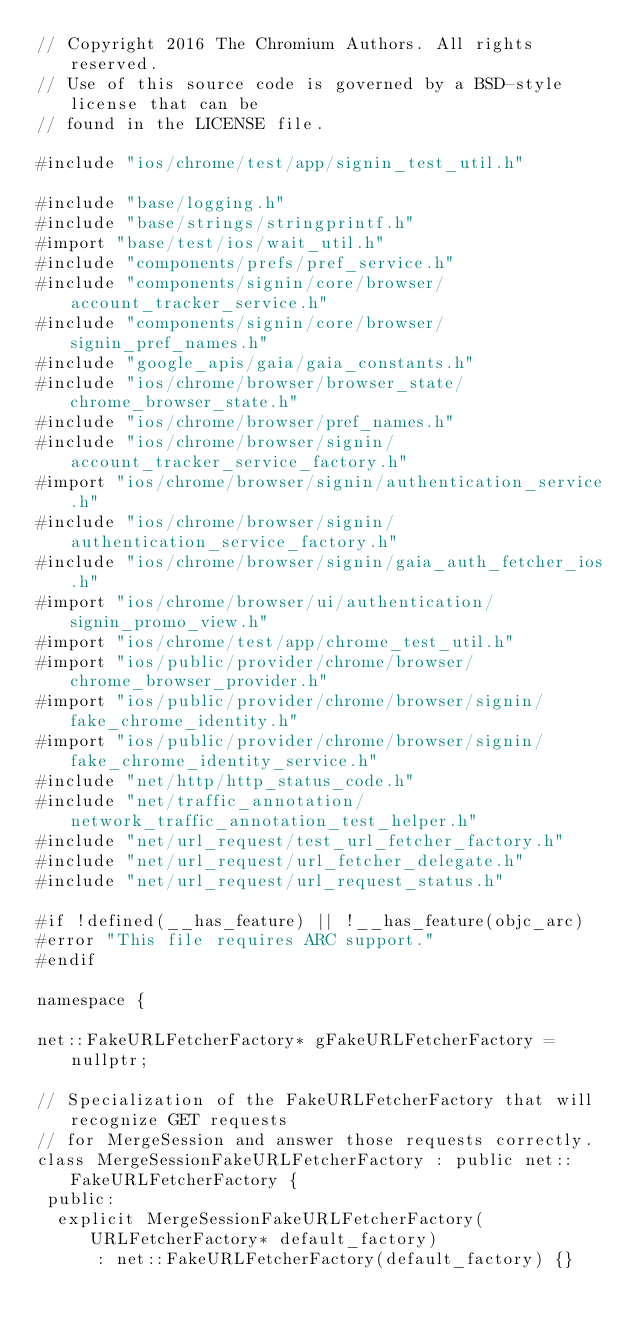Convert code to text. <code><loc_0><loc_0><loc_500><loc_500><_ObjectiveC_>// Copyright 2016 The Chromium Authors. All rights reserved.
// Use of this source code is governed by a BSD-style license that can be
// found in the LICENSE file.

#include "ios/chrome/test/app/signin_test_util.h"

#include "base/logging.h"
#include "base/strings/stringprintf.h"
#import "base/test/ios/wait_util.h"
#include "components/prefs/pref_service.h"
#include "components/signin/core/browser/account_tracker_service.h"
#include "components/signin/core/browser/signin_pref_names.h"
#include "google_apis/gaia/gaia_constants.h"
#include "ios/chrome/browser/browser_state/chrome_browser_state.h"
#include "ios/chrome/browser/pref_names.h"
#include "ios/chrome/browser/signin/account_tracker_service_factory.h"
#import "ios/chrome/browser/signin/authentication_service.h"
#include "ios/chrome/browser/signin/authentication_service_factory.h"
#include "ios/chrome/browser/signin/gaia_auth_fetcher_ios.h"
#import "ios/chrome/browser/ui/authentication/signin_promo_view.h"
#import "ios/chrome/test/app/chrome_test_util.h"
#import "ios/public/provider/chrome/browser/chrome_browser_provider.h"
#import "ios/public/provider/chrome/browser/signin/fake_chrome_identity.h"
#import "ios/public/provider/chrome/browser/signin/fake_chrome_identity_service.h"
#include "net/http/http_status_code.h"
#include "net/traffic_annotation/network_traffic_annotation_test_helper.h"
#include "net/url_request/test_url_fetcher_factory.h"
#include "net/url_request/url_fetcher_delegate.h"
#include "net/url_request/url_request_status.h"

#if !defined(__has_feature) || !__has_feature(objc_arc)
#error "This file requires ARC support."
#endif

namespace {

net::FakeURLFetcherFactory* gFakeURLFetcherFactory = nullptr;

// Specialization of the FakeURLFetcherFactory that will recognize GET requests
// for MergeSession and answer those requests correctly.
class MergeSessionFakeURLFetcherFactory : public net::FakeURLFetcherFactory {
 public:
  explicit MergeSessionFakeURLFetcherFactory(URLFetcherFactory* default_factory)
      : net::FakeURLFetcherFactory(default_factory) {}</code> 